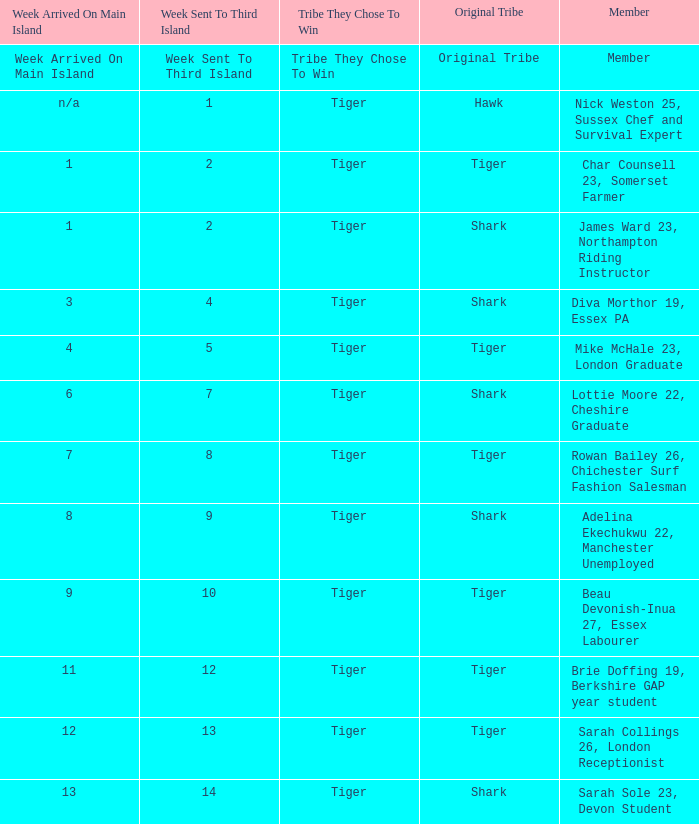What week was the member who arrived on the main island in week 6 sent to the third island? 7.0. 